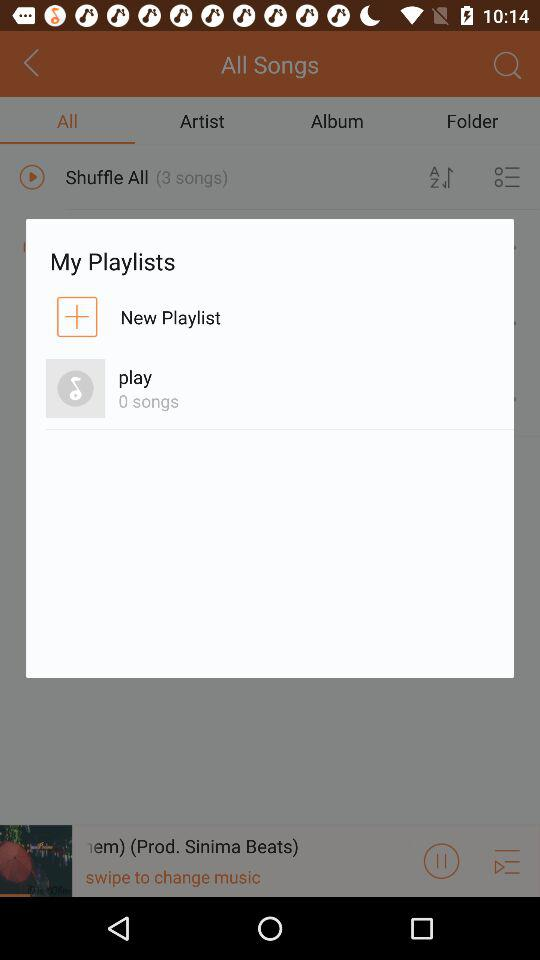How many songs are there in "play"? There are 0 songs in "play". 